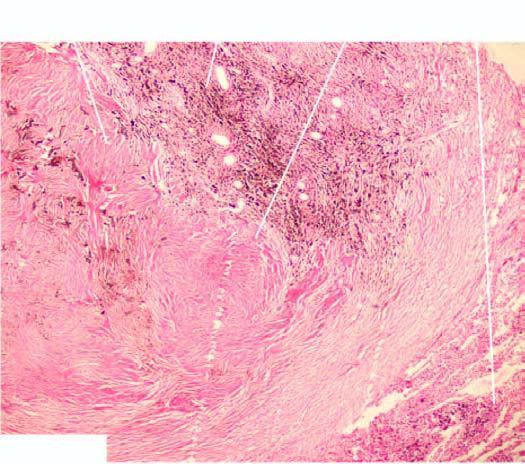what are distended?
Answer the question using a single word or phrase. Alveoli and respiratory bronchioles surrounding the coal macule 